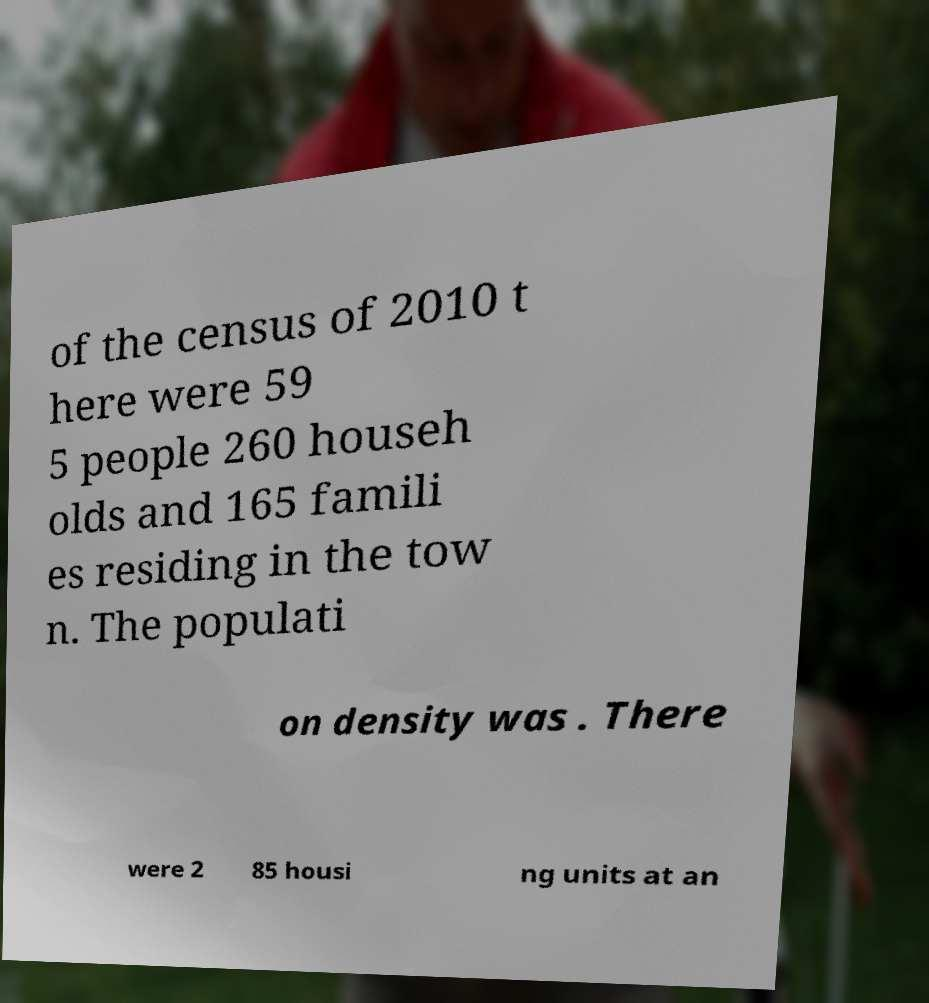Can you accurately transcribe the text from the provided image for me? of the census of 2010 t here were 59 5 people 260 househ olds and 165 famili es residing in the tow n. The populati on density was . There were 2 85 housi ng units at an 